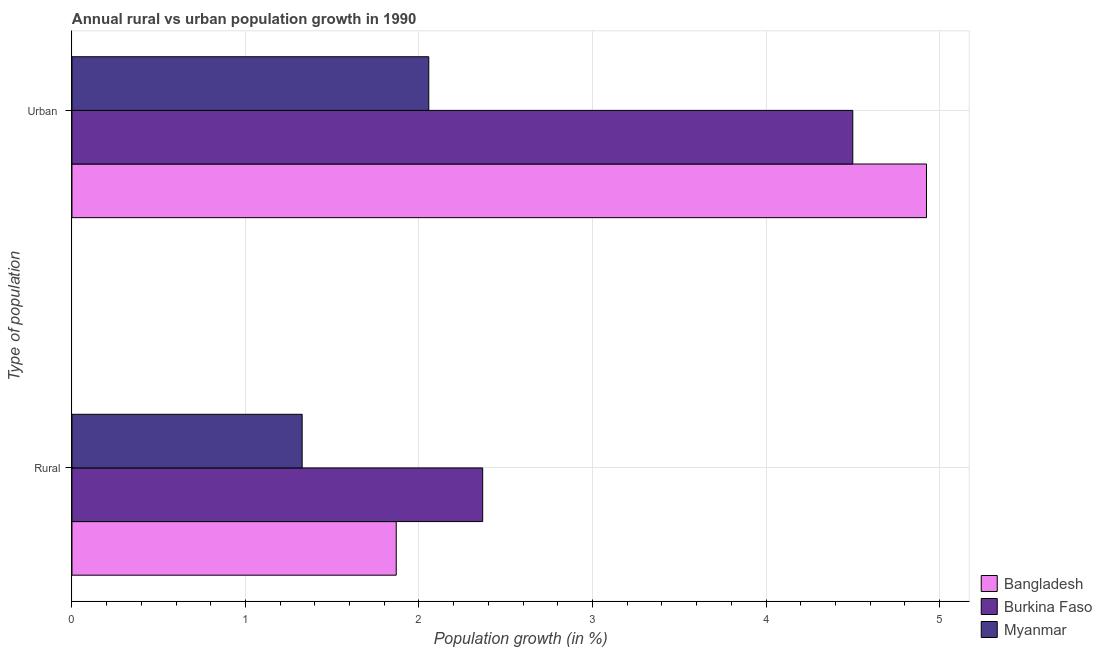How many groups of bars are there?
Offer a very short reply. 2. How many bars are there on the 2nd tick from the top?
Make the answer very short. 3. What is the label of the 2nd group of bars from the top?
Provide a short and direct response. Rural. What is the rural population growth in Bangladesh?
Provide a succinct answer. 1.87. Across all countries, what is the maximum urban population growth?
Provide a succinct answer. 4.92. Across all countries, what is the minimum rural population growth?
Ensure brevity in your answer.  1.33. In which country was the rural population growth maximum?
Provide a short and direct response. Burkina Faso. In which country was the rural population growth minimum?
Provide a short and direct response. Myanmar. What is the total rural population growth in the graph?
Your response must be concise. 5.56. What is the difference between the rural population growth in Burkina Faso and that in Bangladesh?
Your response must be concise. 0.5. What is the difference between the urban population growth in Myanmar and the rural population growth in Bangladesh?
Your response must be concise. 0.19. What is the average rural population growth per country?
Provide a succinct answer. 1.85. What is the difference between the rural population growth and urban population growth in Bangladesh?
Make the answer very short. -3.06. What is the ratio of the rural population growth in Myanmar to that in Bangladesh?
Your response must be concise. 0.71. Is the rural population growth in Burkina Faso less than that in Bangladesh?
Your answer should be compact. No. What does the 1st bar from the top in Rural represents?
Make the answer very short. Myanmar. What does the 3rd bar from the bottom in Rural represents?
Give a very brief answer. Myanmar. Are all the bars in the graph horizontal?
Offer a terse response. Yes. How many countries are there in the graph?
Keep it short and to the point. 3. Are the values on the major ticks of X-axis written in scientific E-notation?
Keep it short and to the point. No. Does the graph contain grids?
Your answer should be very brief. Yes. How many legend labels are there?
Provide a short and direct response. 3. What is the title of the graph?
Offer a terse response. Annual rural vs urban population growth in 1990. What is the label or title of the X-axis?
Keep it short and to the point. Population growth (in %). What is the label or title of the Y-axis?
Your answer should be very brief. Type of population. What is the Population growth (in %) in Bangladesh in Rural?
Keep it short and to the point. 1.87. What is the Population growth (in %) of Burkina Faso in Rural?
Your answer should be compact. 2.37. What is the Population growth (in %) in Myanmar in Rural?
Provide a succinct answer. 1.33. What is the Population growth (in %) in Bangladesh in Urban ?
Your response must be concise. 4.92. What is the Population growth (in %) of Burkina Faso in Urban ?
Provide a succinct answer. 4.5. What is the Population growth (in %) in Myanmar in Urban ?
Make the answer very short. 2.06. Across all Type of population, what is the maximum Population growth (in %) of Bangladesh?
Your answer should be very brief. 4.92. Across all Type of population, what is the maximum Population growth (in %) in Burkina Faso?
Your response must be concise. 4.5. Across all Type of population, what is the maximum Population growth (in %) in Myanmar?
Offer a very short reply. 2.06. Across all Type of population, what is the minimum Population growth (in %) in Bangladesh?
Give a very brief answer. 1.87. Across all Type of population, what is the minimum Population growth (in %) in Burkina Faso?
Keep it short and to the point. 2.37. Across all Type of population, what is the minimum Population growth (in %) of Myanmar?
Your response must be concise. 1.33. What is the total Population growth (in %) of Bangladesh in the graph?
Keep it short and to the point. 6.79. What is the total Population growth (in %) in Burkina Faso in the graph?
Make the answer very short. 6.87. What is the total Population growth (in %) of Myanmar in the graph?
Offer a very short reply. 3.38. What is the difference between the Population growth (in %) of Bangladesh in Rural and that in Urban ?
Your answer should be very brief. -3.06. What is the difference between the Population growth (in %) in Burkina Faso in Rural and that in Urban ?
Your response must be concise. -2.13. What is the difference between the Population growth (in %) in Myanmar in Rural and that in Urban ?
Offer a very short reply. -0.73. What is the difference between the Population growth (in %) of Bangladesh in Rural and the Population growth (in %) of Burkina Faso in Urban ?
Keep it short and to the point. -2.63. What is the difference between the Population growth (in %) of Bangladesh in Rural and the Population growth (in %) of Myanmar in Urban ?
Offer a very short reply. -0.19. What is the difference between the Population growth (in %) in Burkina Faso in Rural and the Population growth (in %) in Myanmar in Urban ?
Ensure brevity in your answer.  0.31. What is the average Population growth (in %) of Bangladesh per Type of population?
Ensure brevity in your answer.  3.4. What is the average Population growth (in %) of Burkina Faso per Type of population?
Your response must be concise. 3.43. What is the average Population growth (in %) in Myanmar per Type of population?
Your response must be concise. 1.69. What is the difference between the Population growth (in %) in Bangladesh and Population growth (in %) in Burkina Faso in Rural?
Keep it short and to the point. -0.5. What is the difference between the Population growth (in %) in Bangladesh and Population growth (in %) in Myanmar in Rural?
Ensure brevity in your answer.  0.54. What is the difference between the Population growth (in %) of Burkina Faso and Population growth (in %) of Myanmar in Rural?
Keep it short and to the point. 1.04. What is the difference between the Population growth (in %) in Bangladesh and Population growth (in %) in Burkina Faso in Urban ?
Offer a terse response. 0.42. What is the difference between the Population growth (in %) of Bangladesh and Population growth (in %) of Myanmar in Urban ?
Give a very brief answer. 2.87. What is the difference between the Population growth (in %) of Burkina Faso and Population growth (in %) of Myanmar in Urban ?
Offer a terse response. 2.44. What is the ratio of the Population growth (in %) in Bangladesh in Rural to that in Urban ?
Ensure brevity in your answer.  0.38. What is the ratio of the Population growth (in %) in Burkina Faso in Rural to that in Urban ?
Ensure brevity in your answer.  0.53. What is the ratio of the Population growth (in %) in Myanmar in Rural to that in Urban ?
Your answer should be compact. 0.65. What is the difference between the highest and the second highest Population growth (in %) of Bangladesh?
Your answer should be very brief. 3.06. What is the difference between the highest and the second highest Population growth (in %) in Burkina Faso?
Your answer should be very brief. 2.13. What is the difference between the highest and the second highest Population growth (in %) in Myanmar?
Your response must be concise. 0.73. What is the difference between the highest and the lowest Population growth (in %) in Bangladesh?
Offer a very short reply. 3.06. What is the difference between the highest and the lowest Population growth (in %) of Burkina Faso?
Your answer should be very brief. 2.13. What is the difference between the highest and the lowest Population growth (in %) of Myanmar?
Provide a succinct answer. 0.73. 